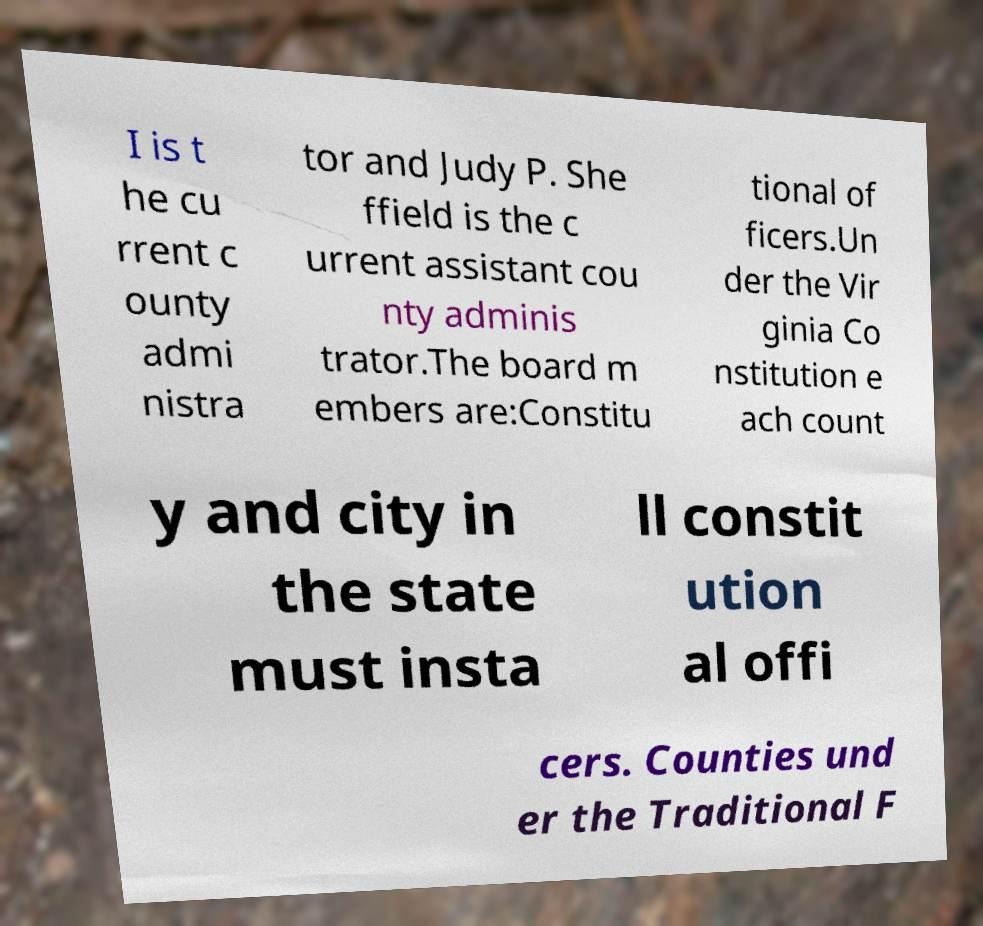What messages or text are displayed in this image? I need them in a readable, typed format. I is t he cu rrent c ounty admi nistra tor and Judy P. She ffield is the c urrent assistant cou nty adminis trator.The board m embers are:Constitu tional of ficers.Un der the Vir ginia Co nstitution e ach count y and city in the state must insta ll constit ution al offi cers. Counties und er the Traditional F 